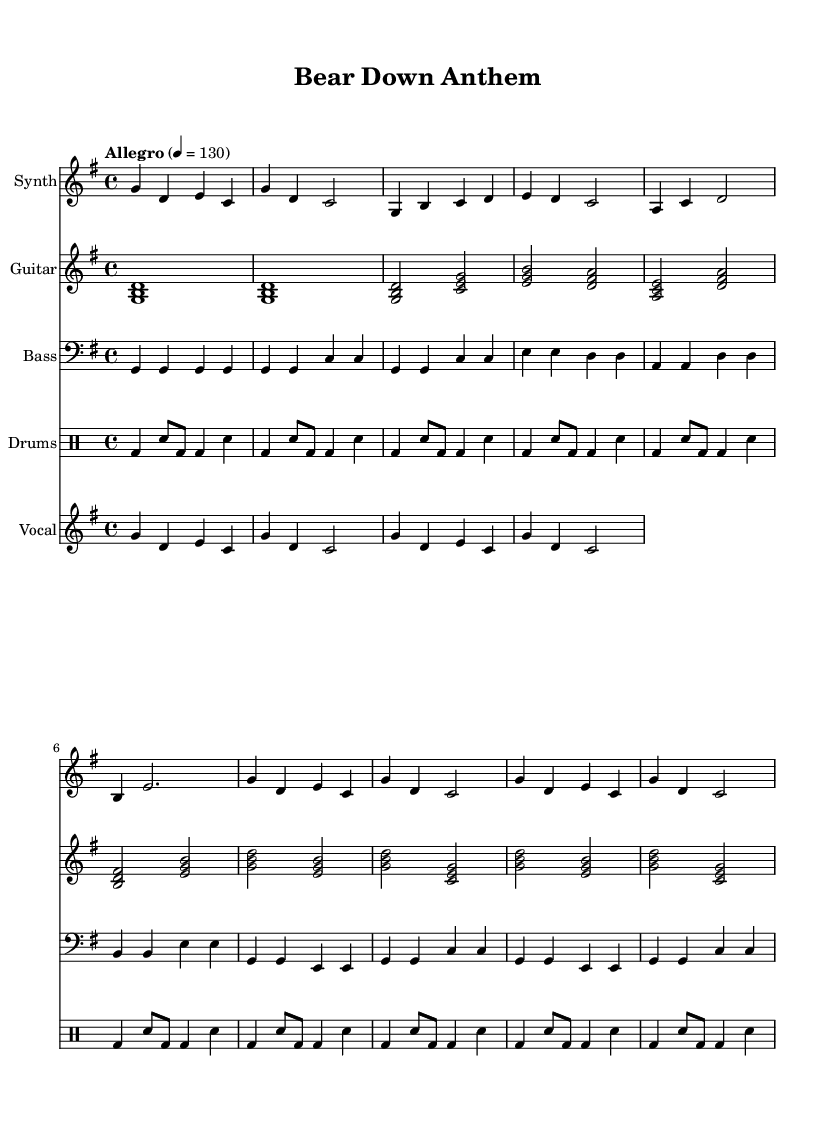What is the key signature of this music? The key signature indicated at the beginning of the sheet music is G major, which has one sharp (F#).
Answer: G major What is the time signature of this music? The time signature shown in the sheet music is 4/4, indicating four beats per measure.
Answer: 4/4 What is the tempo marking of this piece? The tempo marking is "Allegro" with a metronome marking of 130 beats per minute, suggesting a fast tempo.
Answer: Allegro, 130 What type of electronic instrument is used in this score? The score features a Synth, which is a common electronic instrument used in K-Pop music for its distinctive sound.
Answer: Synth What phrase describes the main theme of the lyrics? The lyrics repeatedly emphasize "Bear down, Chi-ca-go Bears," reflecting a sports theme of support and unity for the Chicago Bears.
Answer: Bear down, Chi-ca-go Bears How does the drum pattern contribute to the K-Pop style? The drum pattern consists of a basic four-on-the-floor beat with syncopated snare, typical in K-Pop for creating an engaging dance rhythm.
Answer: Four-on-the-floor with syncopated snare How many measures are in the chorus section of the piece? The chorus section contains four measures as indicated by the repeating musical phrases in the sheet music.
Answer: Four measures 